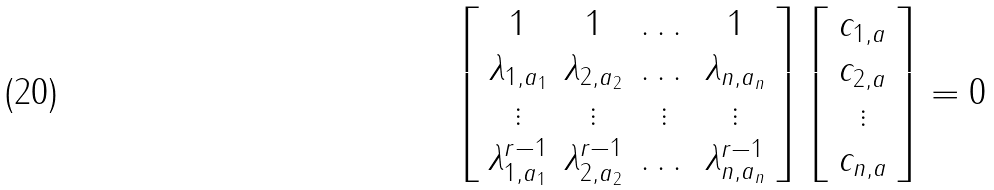<formula> <loc_0><loc_0><loc_500><loc_500>\left [ \begin{array} { c c c c } 1 & 1 & \dots & 1 \\ \lambda _ { 1 , a _ { 1 } } & \lambda _ { 2 , a _ { 2 } } & \dots & \lambda _ { n , a _ { n } } \\ \vdots & \vdots & \vdots & \vdots \\ \lambda _ { 1 , a _ { 1 } } ^ { r - 1 } & \lambda _ { 2 , a _ { 2 } } ^ { r - 1 } & \dots & \lambda _ { n , a _ { n } } ^ { r - 1 } \end{array} \right ] \left [ \begin{array} { c } c _ { 1 , a } \\ c _ { 2 , a } \\ \vdots \\ c _ { n , a } \\ \end{array} \right ] = 0</formula> 